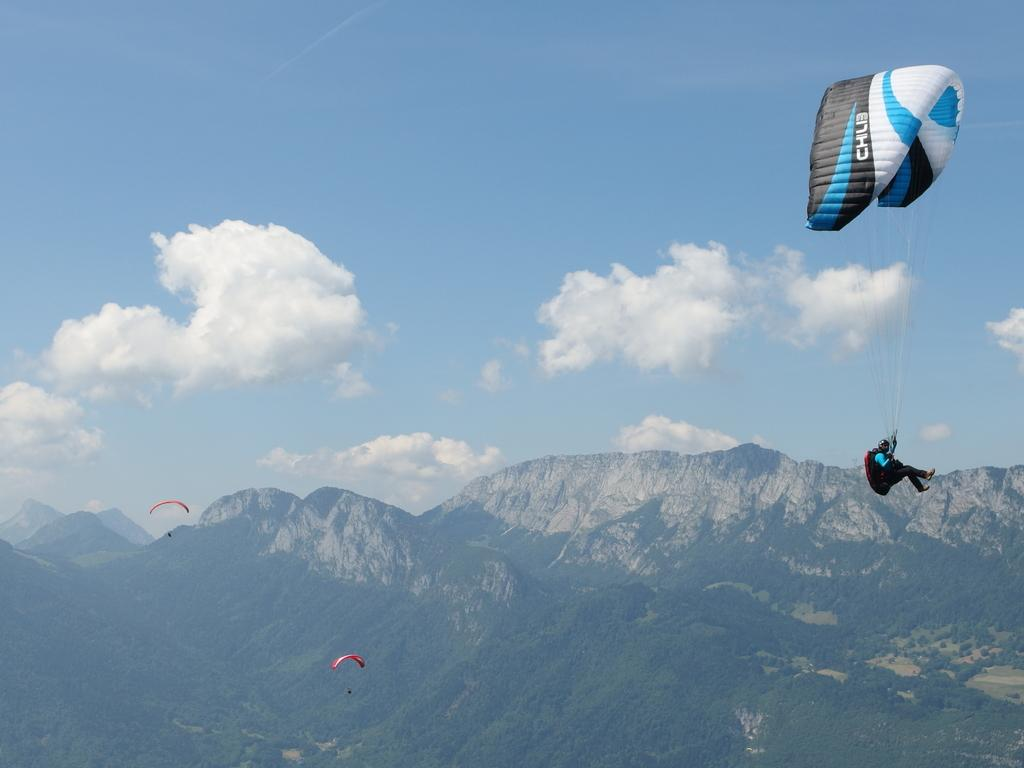What are the people doing in the image? There are paragliders in the image, so the people are paragliding. Can you describe the person in the air on the right side of the image? A person is in the air on the right side of the image, likely paragliding as well. What can be seen in the distance in the image? There are hills visible in the background of the image, along with trees and a cloudy sky. How many bottles of water are being carried by the deer in the image? There are no deer or bottles of water present in the image. 